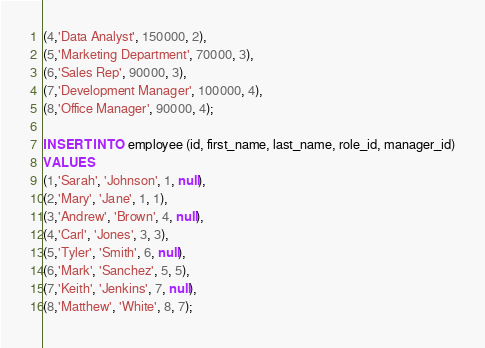<code> <loc_0><loc_0><loc_500><loc_500><_SQL_>(4,'Data Analyst', 150000, 2),
(5,'Marketing Department', 70000, 3), 
(6,'Sales Rep', 90000, 3),
(7,'Development Manager', 100000, 4),
(8,'Office Manager', 90000, 4);

INSERT INTO employee (id, first_name, last_name, role_id, manager_id)
VALUES 
(1,'Sarah', 'Johnson', 1, null),
(2,'Mary', 'Jane', 1, 1),
(3,'Andrew', 'Brown', 4, null),
(4,'Carl', 'Jones', 3, 3),
(5,'Tyler', 'Smith', 6, null),
(6,'Mark', 'Sanchez', 5, 5),
(7,'Keith', 'Jenkins', 7, null),
(8,'Matthew', 'White', 8, 7);
</code> 